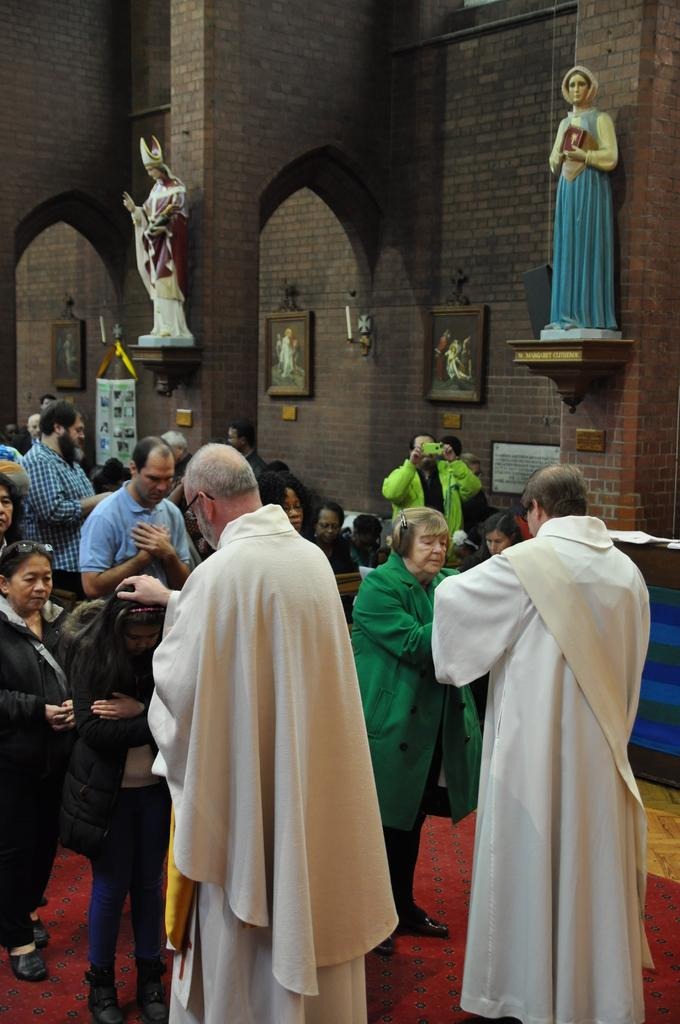How many people are in the image? There is a group of people in the image, but the exact number is not specified. What can be seen in the background of the image? There are statues and frames on the wall in the background of the image. What is a person in the image holding? A person is holding a camera in the image. What type of waves can be seen crashing against the shore in the image? There is no reference to waves or a shore in the image; it features a group of people, statues, frames, and a person holding a camera. 